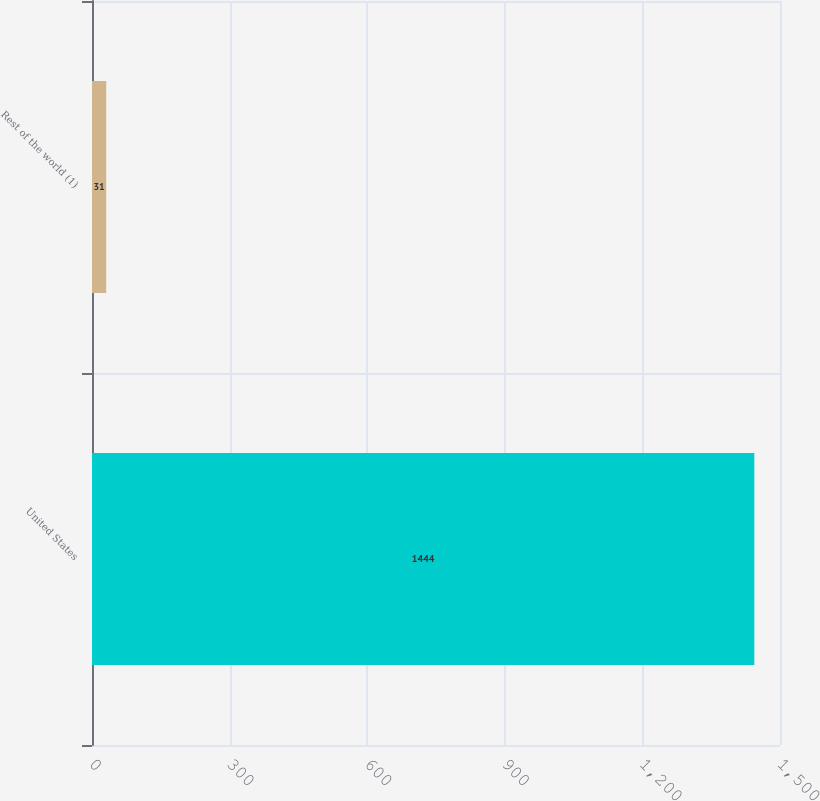Convert chart. <chart><loc_0><loc_0><loc_500><loc_500><bar_chart><fcel>United States<fcel>Rest of the world (1)<nl><fcel>1444<fcel>31<nl></chart> 